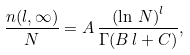Convert formula to latex. <formula><loc_0><loc_0><loc_500><loc_500>\frac { n ( l , \infty ) } { N } = A \, \frac { \left ( \ln \, N \right ) ^ { l } } { \Gamma ( B \, l + C ) } ,</formula> 